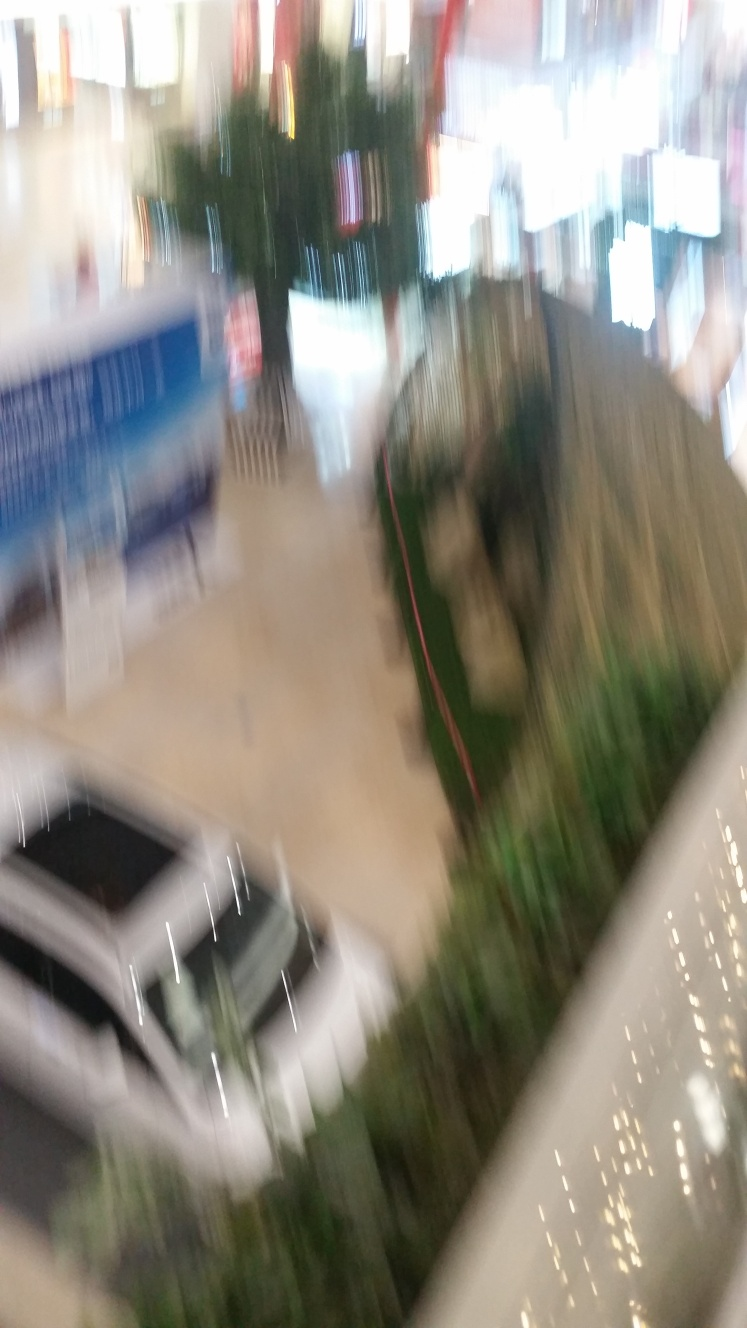What might have caused the blurriness in the photograph? The blurriness could be due to camera motion, a slow shutter speed during the capture, or a focus error, possibly because the photo was taken hastily or in a setting with insufficient lighting. 